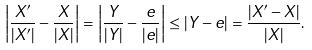<formula> <loc_0><loc_0><loc_500><loc_500>\left | \frac { X ^ { \prime } } { | X ^ { \prime } | } - \frac { X } { | X | } \right | = \left | \frac { Y } { | Y | } - \frac { e } { | e | } \right | \leq | Y - e | = \frac { \left | X ^ { \prime } - X \right | } { | X | } .</formula> 